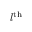Convert formula to latex. <formula><loc_0><loc_0><loc_500><loc_500>l ^ { t h }</formula> 